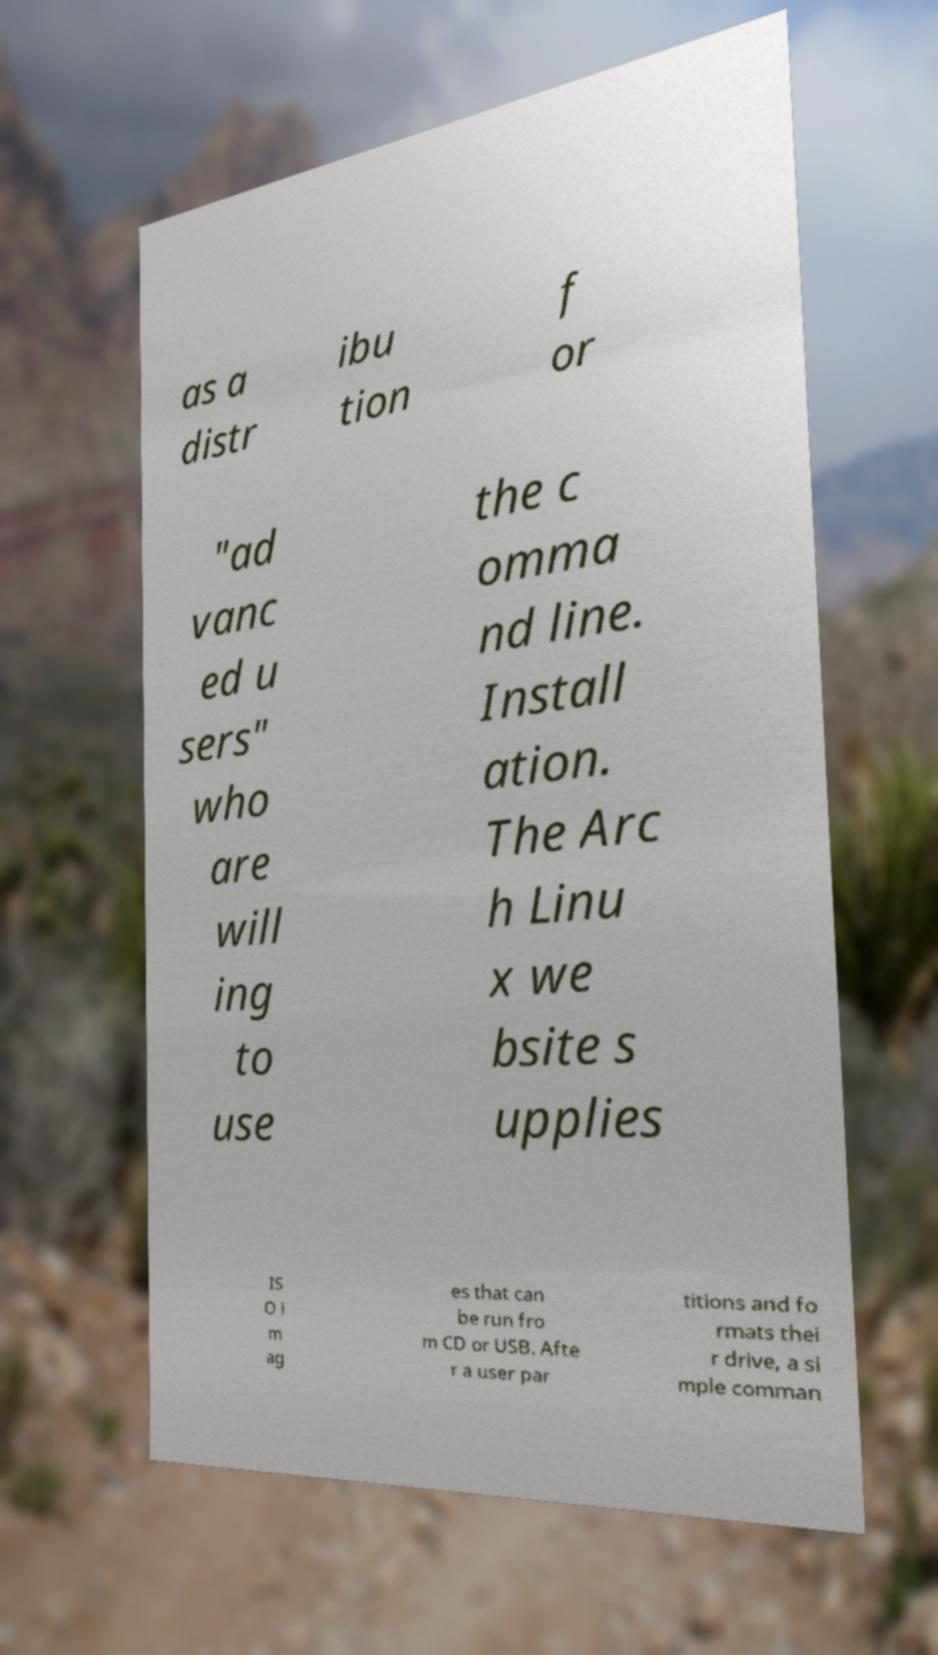Can you read and provide the text displayed in the image?This photo seems to have some interesting text. Can you extract and type it out for me? as a distr ibu tion f or "ad vanc ed u sers" who are will ing to use the c omma nd line. Install ation. The Arc h Linu x we bsite s upplies IS O i m ag es that can be run fro m CD or USB. Afte r a user par titions and fo rmats thei r drive, a si mple comman 